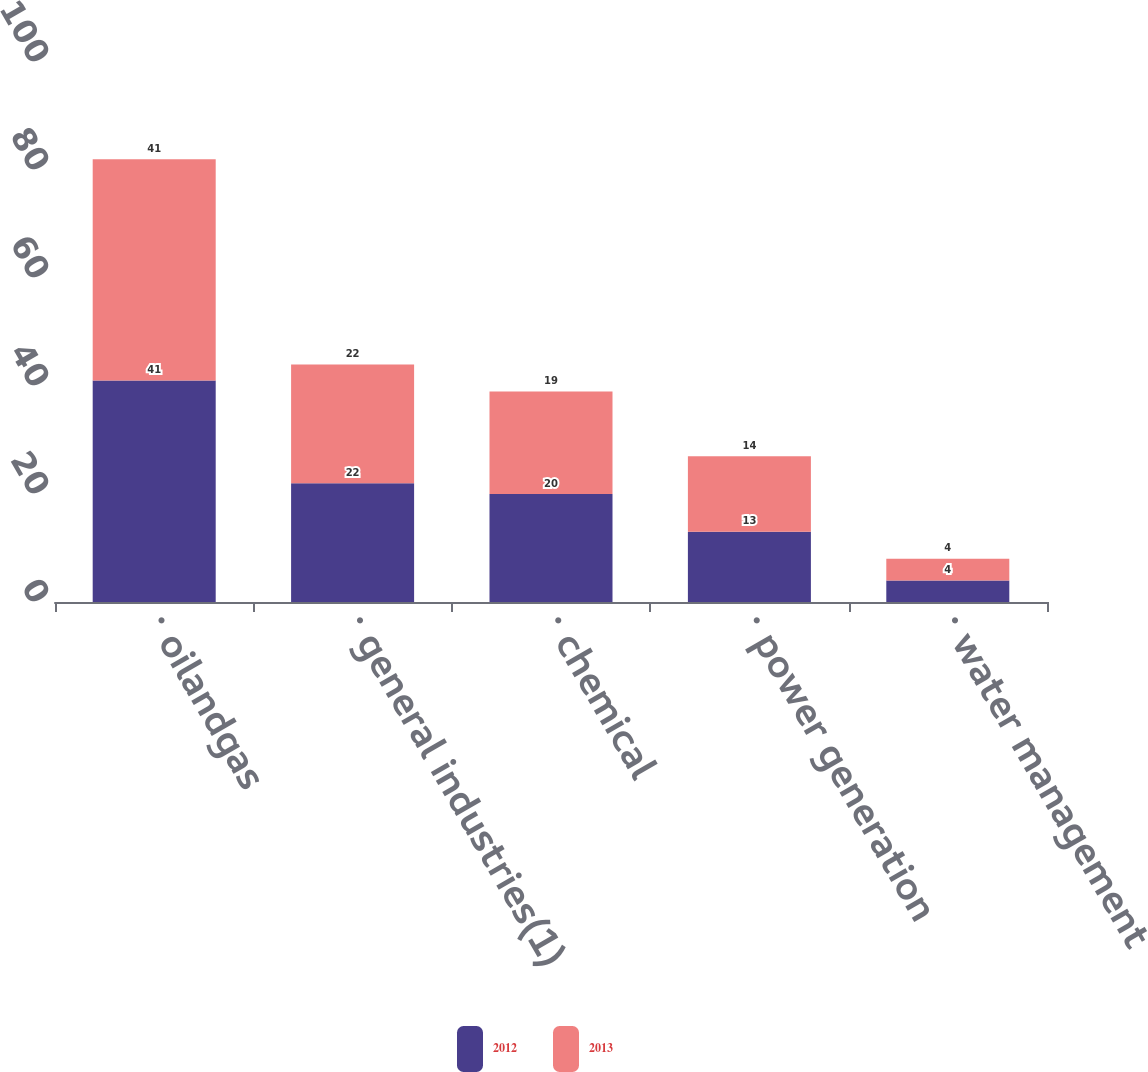Convert chart to OTSL. <chart><loc_0><loc_0><loc_500><loc_500><stacked_bar_chart><ecel><fcel>· oilandgas<fcel>· general industries(1)<fcel>· chemical<fcel>· power generation<fcel>· water management<nl><fcel>2012<fcel>41<fcel>22<fcel>20<fcel>13<fcel>4<nl><fcel>2013<fcel>41<fcel>22<fcel>19<fcel>14<fcel>4<nl></chart> 